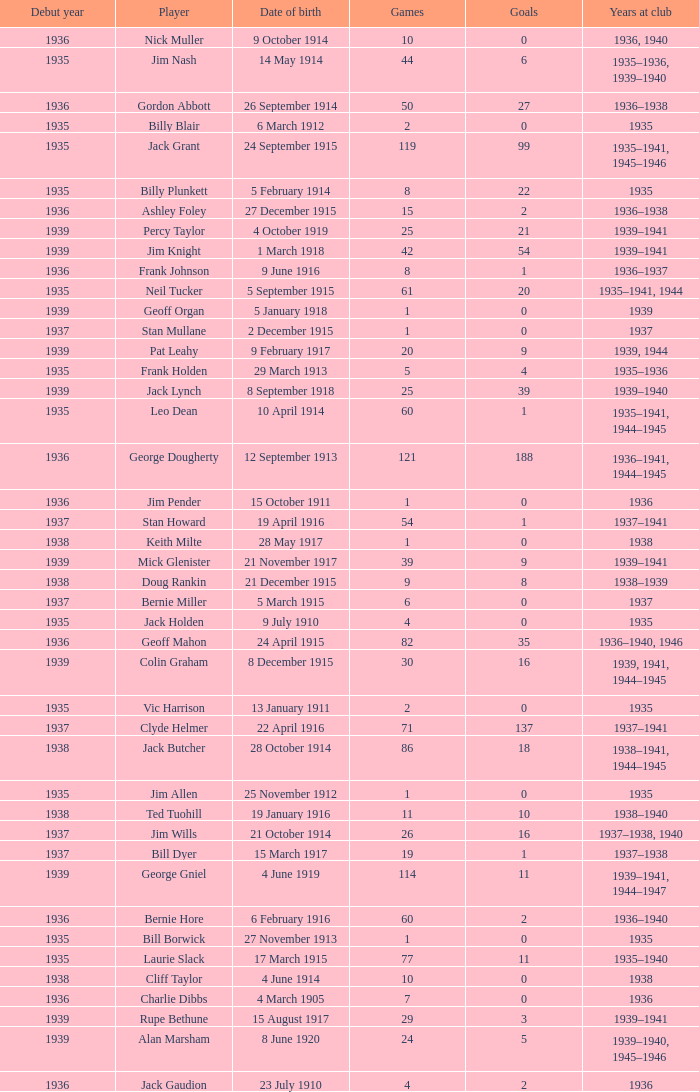How many games, on average, did a player born on march 17, 1915, who started their career before 1935, play? None. 